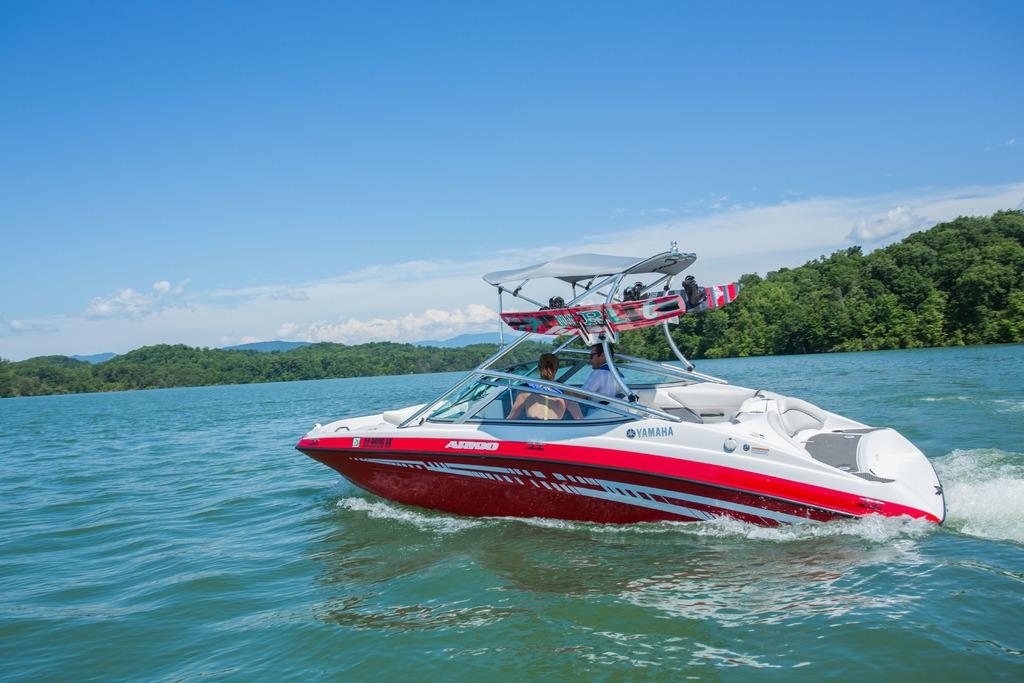What is the main subject of the image? The main subject of the image is a boat above the water. How many people are in the boat? There are two people in the boat. What can be seen in the background of the image? There are trees in the background of the image. What is the color of the sky in the image? The sky is blue in color. What else can be seen in the sky? There are clouds visible in the sky. What type of drawer is visible in the image? There is no drawer present in the image; it features a boat above the water with two people in it. What emotion might the people in the boat be feeling in the image? The image does not provide any information about the emotions of the people in the boat, so it cannot be determined from the image. 